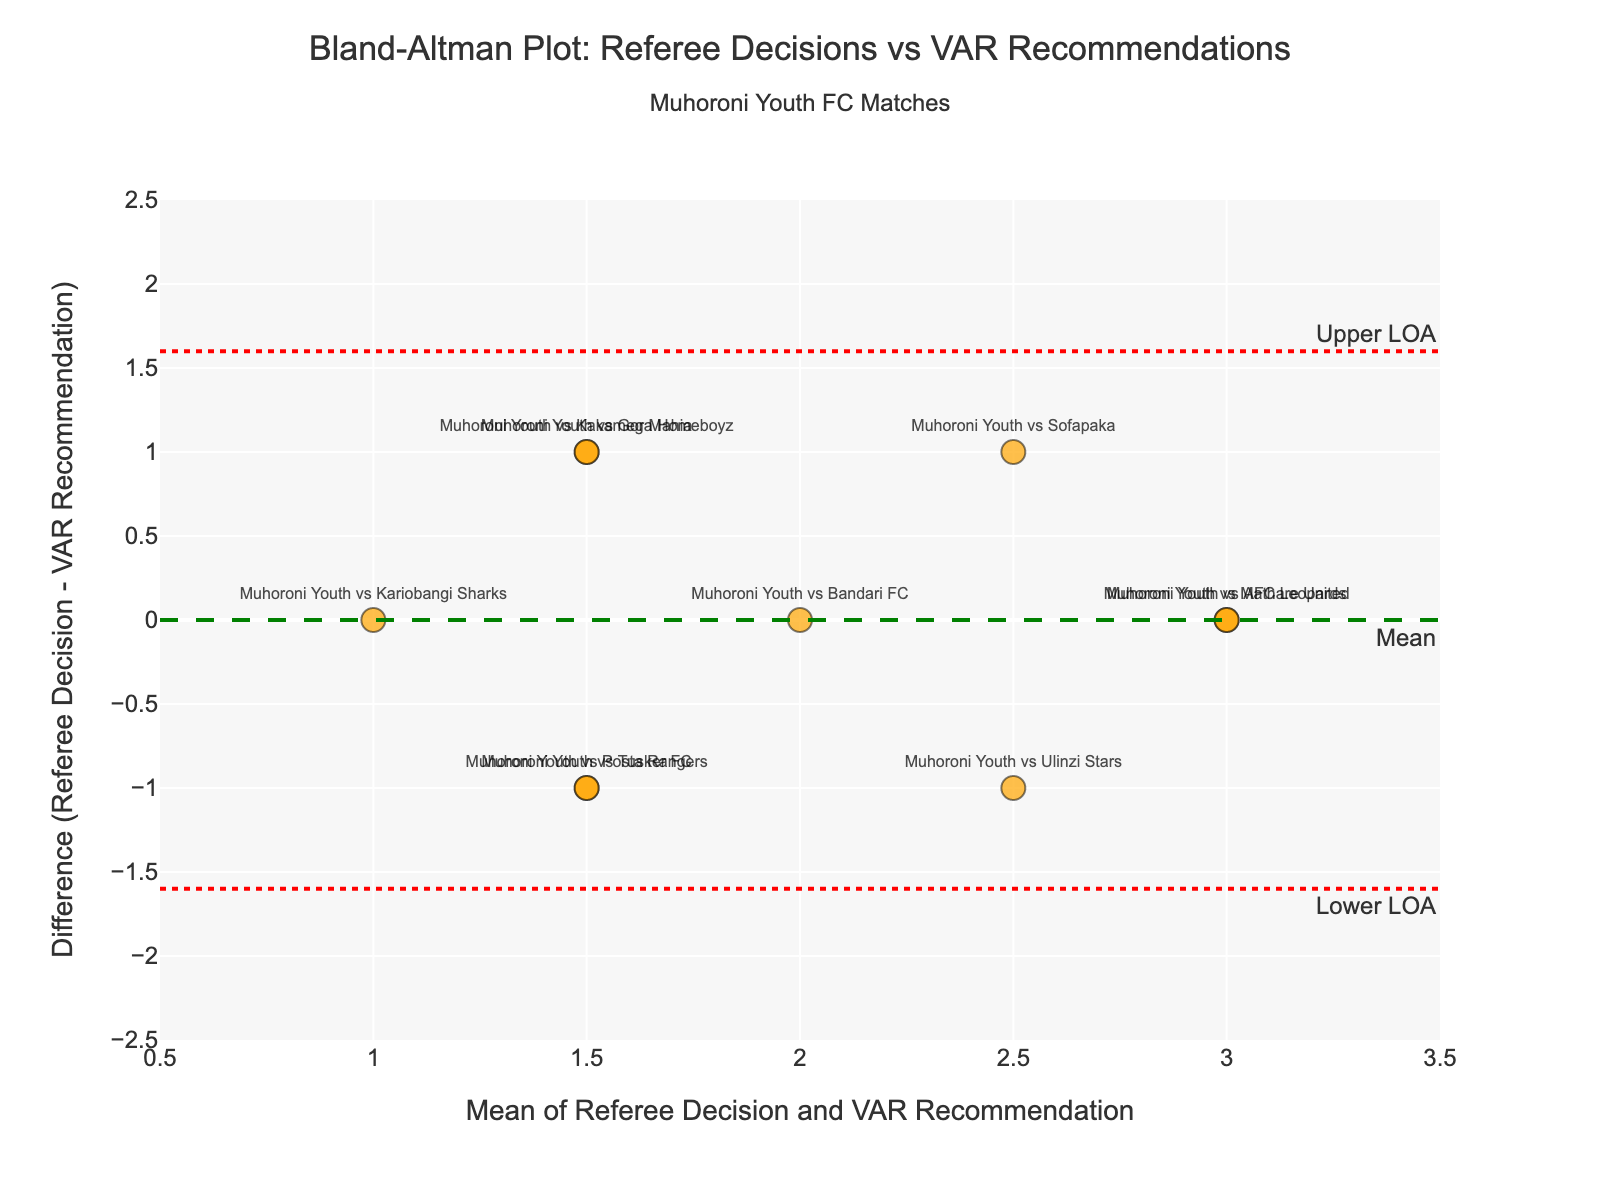What is the difference (Referee Decision - VAR Recommendation) when Muhoroni Youth played against AFC Leopards? The data point for the match "Muhoroni Youth vs AFC Leopards" must be located on the plot. Its difference value is positioned on the y-axis. Locate the match's text on the scatter plot and read off the corresponding y-axis value.
Answer: 0 How many data points indicate that the referee's decision and VAR recommendation were equal? Points where the difference is zero indicate equality. Look for all points that lie on the horizontal line y = 0. Count these points.
Answer: 2 What is the range of the x-axis? The range of the x-axis is displayed by its minimum and maximum values. Inspect the x-axis to see its limits.
Answer: 0.5 to 3.5 What is the average of referee decision and VAR recommendation for the "Muhoroni Youth vs Gor Mahia" match? Find the point corresponding to "Muhoroni Youth vs Gor Mahia." The x-axis value represents the mean of the referee decision and VAR recommendation. Locate this match's text on the scatter plot and read off the x-axis value.
Answer: 1.5 Which match has the highest positive difference (Referee Decision - VAR Recommendation)? Identify the point that is highest above the x-axis on the plot. The match associated with this point has the highest positive difference. Refer to the text label next to this point.
Answer: Muhoroni Youth vs Ulinzi Stars What are the values of the mean difference and the limits of agreement (LOA)? The mean difference is the value of the dashed green line, and the limits of agreement are the values of the dotted red lines. Locate the annotations or the position of these lines on the y-axis.
Answer: Mean difference: 0.0, Upper LOA: 1.78, Lower LOA: -1.78 What is the y-axis value for the "Muhoroni Youth vs Posta Rangers" match? Locate the "Muhoroni Youth vs Posta Rangers" text on the scatter plot. Read the corresponding y-axis value for this point.
Answer: -1 How many points fall outside the limits of agreement? Points outside the LOA are those above the upper LOA line or below the lower LOA line. Count the number of points beyond these dotted red lines.
Answer: 0 What is the difference between the referee decision and VAR recommendation when the mean is 2.5? Find the points where the x-axis value is 2.5. Read the y-axis value for this point to determine the difference.
Answer: 0 In which part of the plot (upper, lower, middle) are most matches located? Visually estimate the density of points in different sections of the plot, considering the y-axis range.
Answer: Middle 